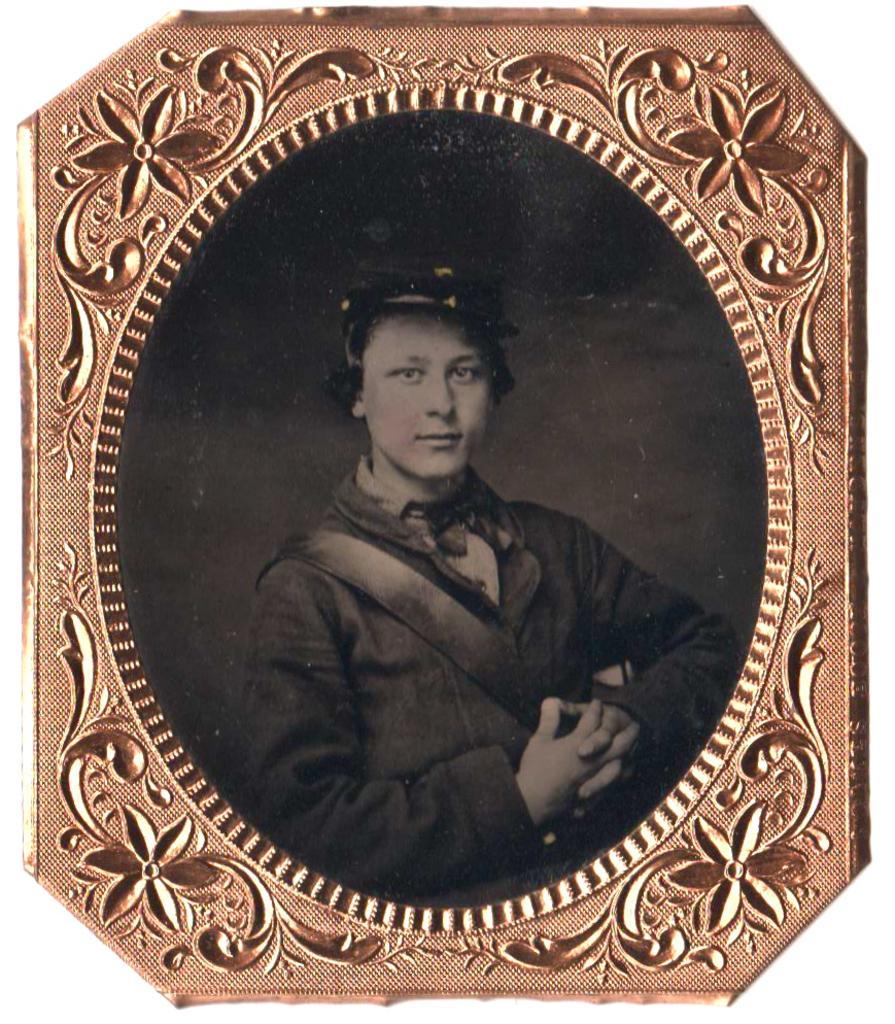Please provide a concise description of this image. In this image there is a picture frame having a person image. He is wearing a cap. 